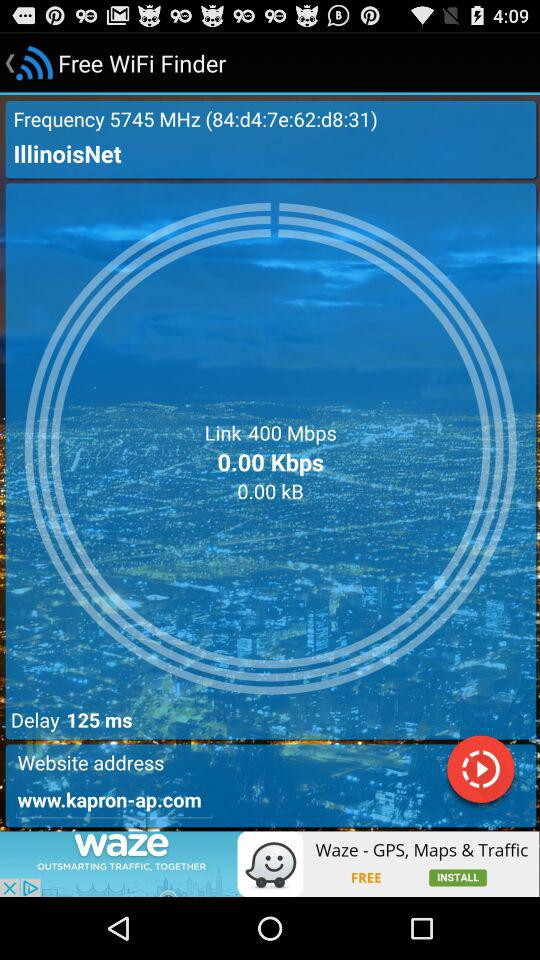How much is the latency of the network in milliseconds?
Answer the question using a single word or phrase. 125 